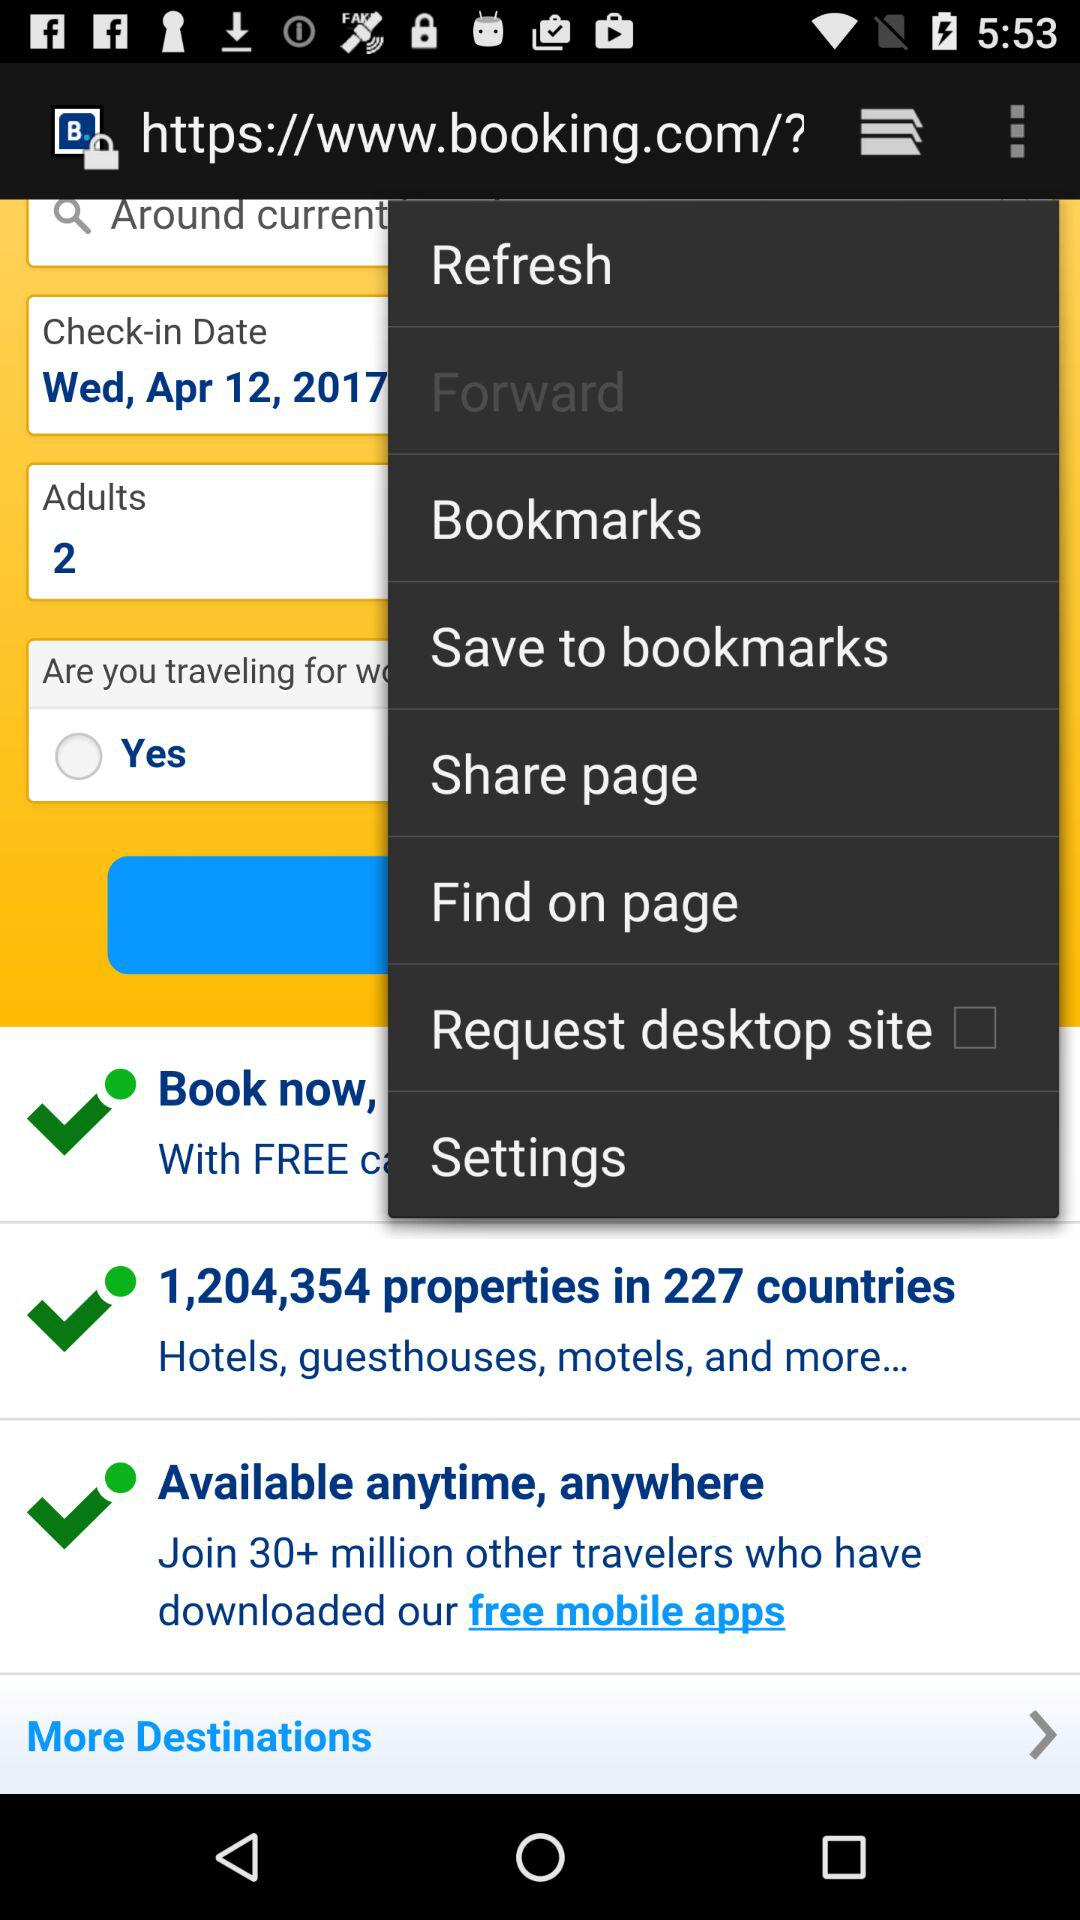How many check-in dates are available?
Answer the question using a single word or phrase. 1 